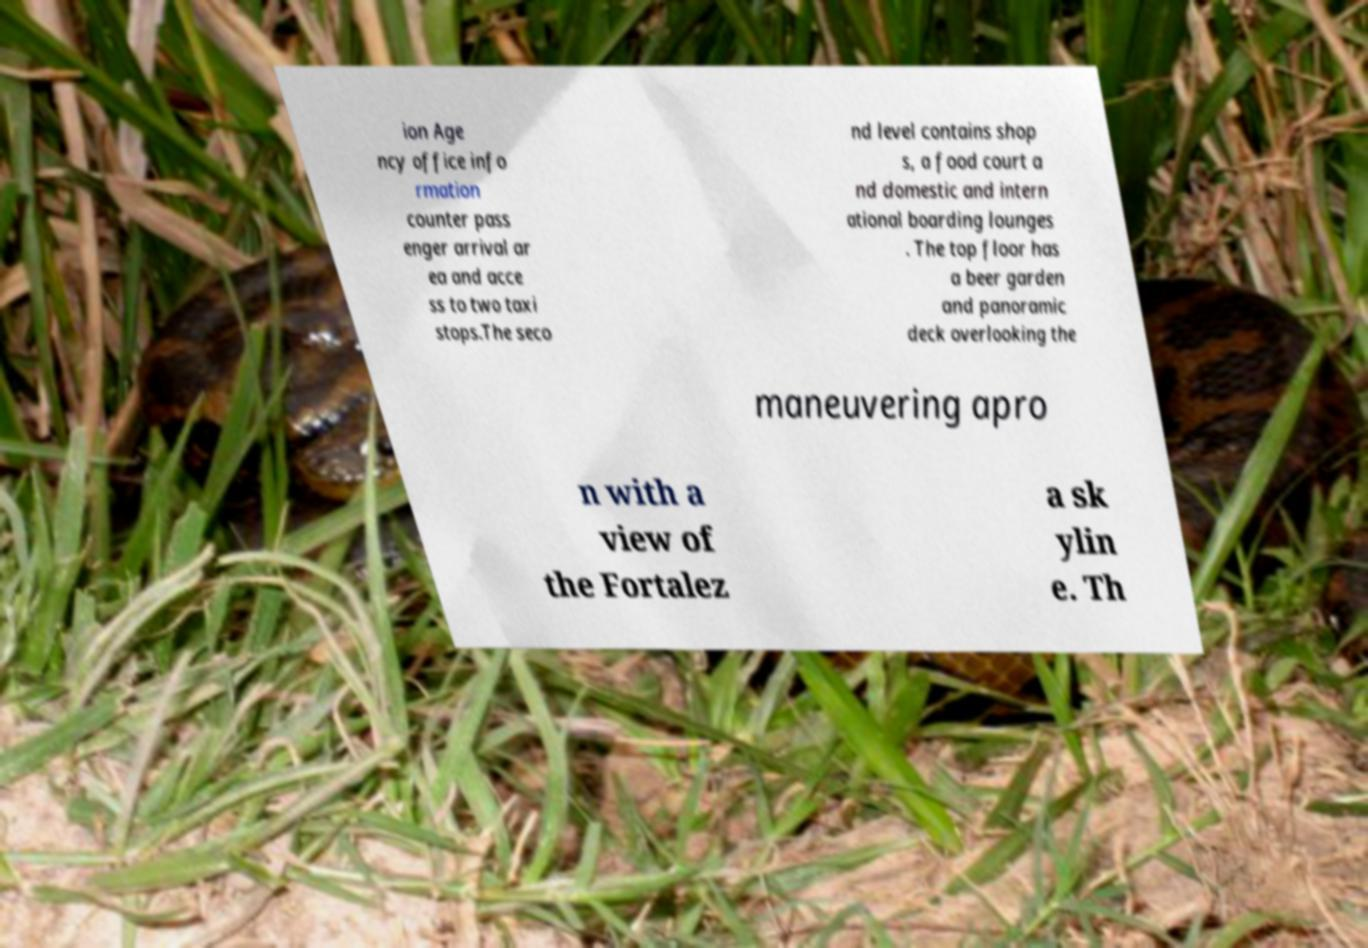Could you assist in decoding the text presented in this image and type it out clearly? ion Age ncy office info rmation counter pass enger arrival ar ea and acce ss to two taxi stops.The seco nd level contains shop s, a food court a nd domestic and intern ational boarding lounges . The top floor has a beer garden and panoramic deck overlooking the maneuvering apro n with a view of the Fortalez a sk ylin e. Th 